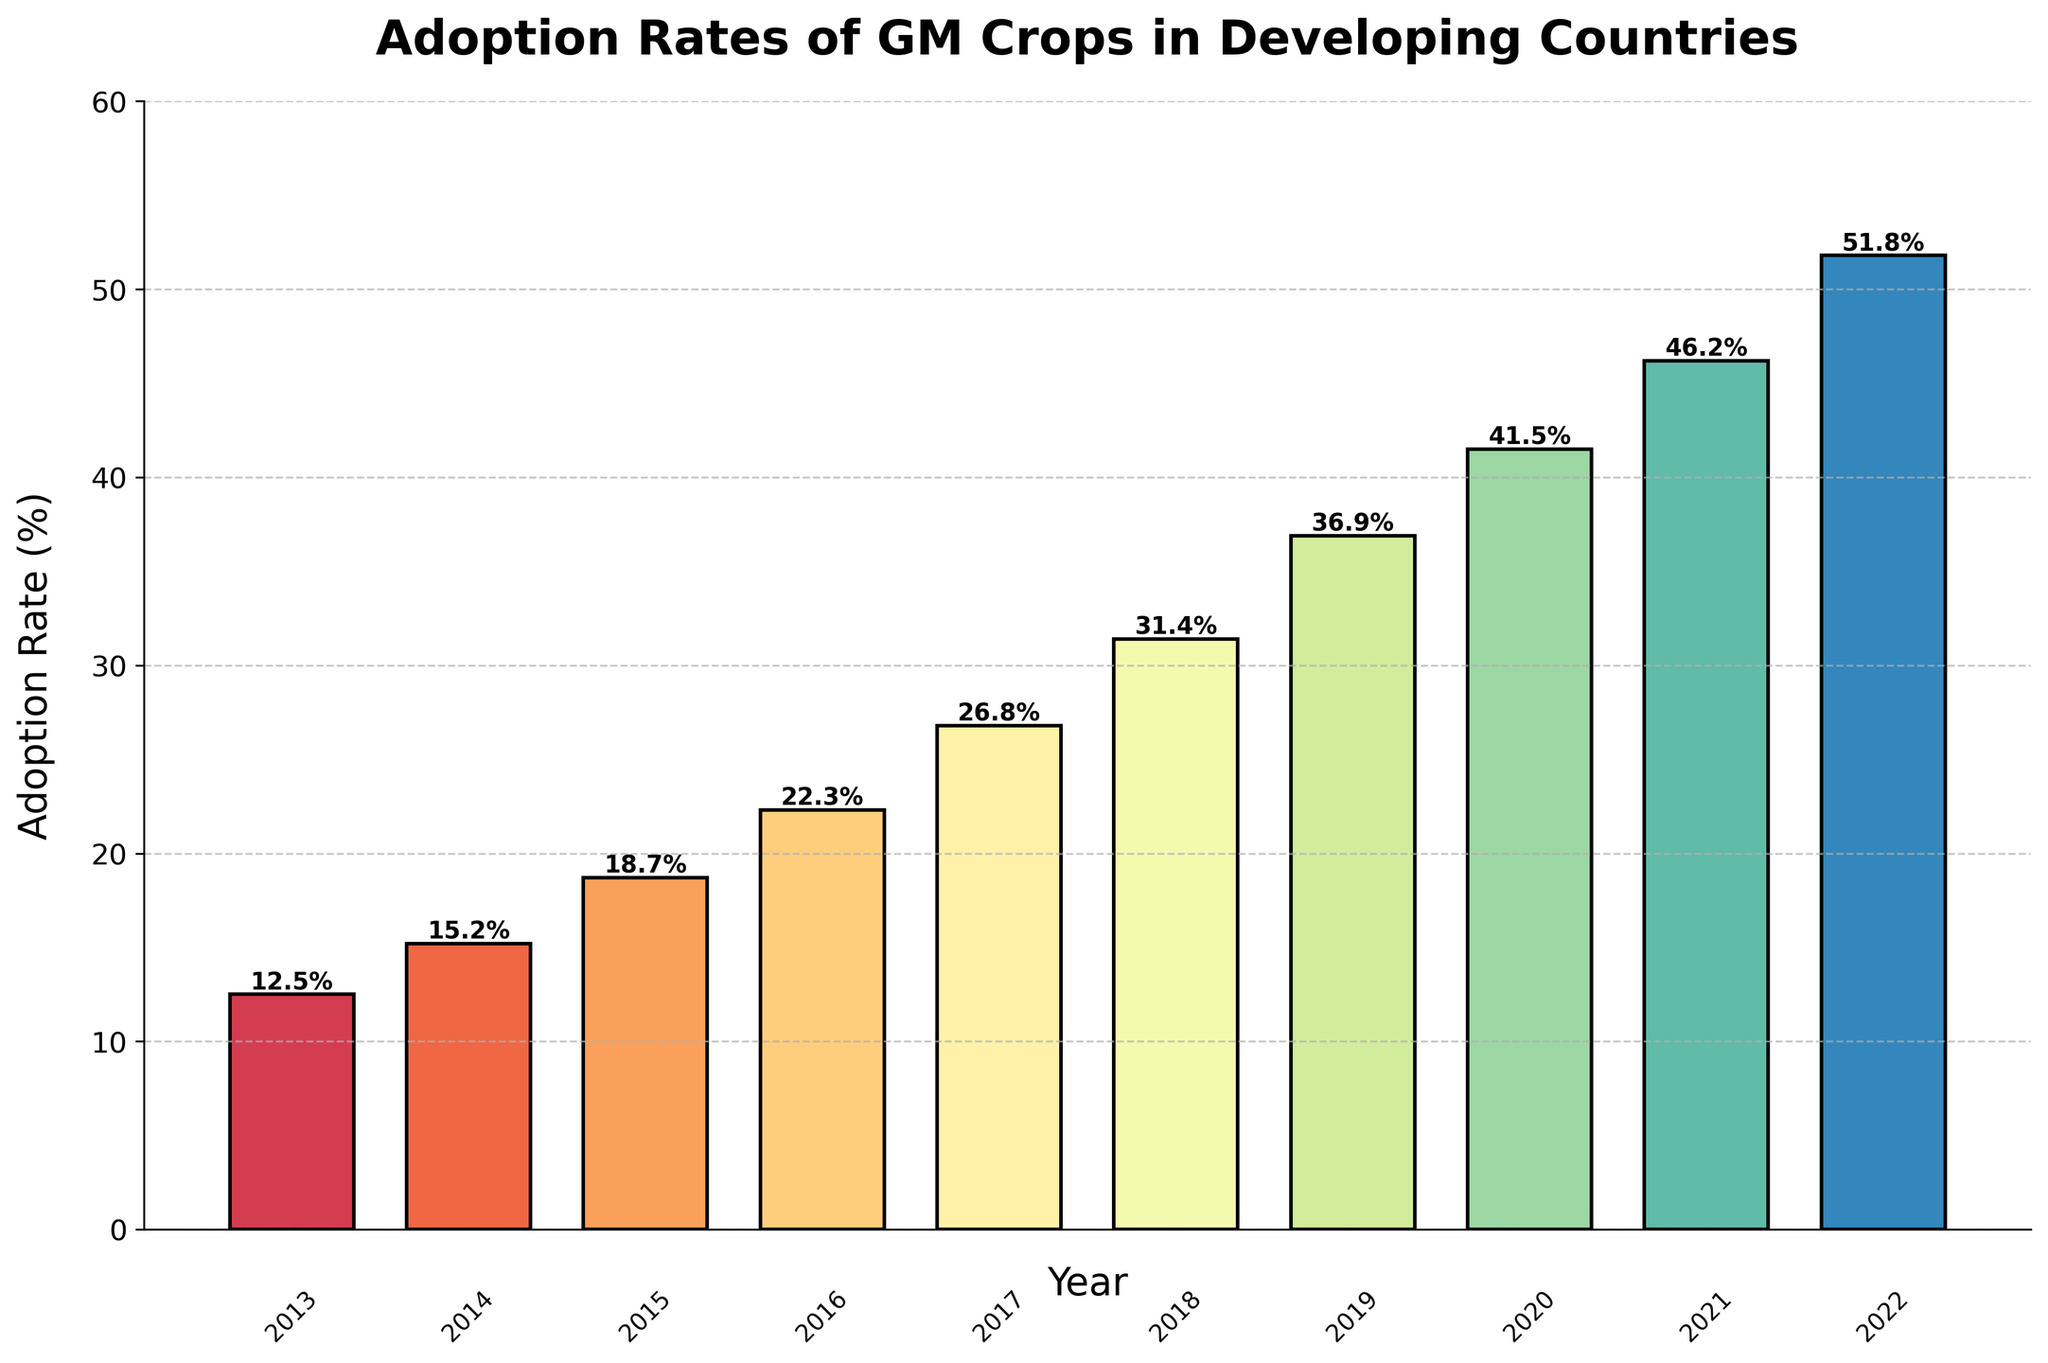What is the adoption rate of GM crops in 2017? The year 2017 corresponds to the label on the x-axis, and the height of the bar at 2017 indicates the adoption rate. The number at the top of the bar also reads 26.8%.
Answer: 26.8% Which year saw the largest adoption rate of GM crops? Observing the height of all the bars, the bar for the year 2022 is the tallest, indicating the highest adoption rate. The number at the top of the bar reads 51.8%.
Answer: 2022 How much did the adoption rate increase from 2013 to 2022? The adoption rate in 2013 is 12.5%, and in 2022 it is 51.8%. Subtracting these values gives the increase: 51.8% - 12.5% = 39.3%.
Answer: 39.3% What was the average adoption rate over the decade? Sum all the adoption rates from 2013 to 2022 and divide by the number of years (10): (12.5 + 15.2 + 18.7 + 22.3 + 26.8 + 31.4 + 36.9 + 41.5 + 46.2 + 51.8) / 10. The total is 303.3, so the average is 303.3 / 10 = 30.33%.
Answer: 30.33% In which year did the adoption rate exceed 40% for the first time? Observing the bars, 2020 is the first year where the adoption rate bar exceeds the 40% mark. The number on top of the bar reads 41.5%.
Answer: 2020 How many years did it take for the adoption rate to double from 12.5%? Starting from 2013 with 12.5%, we look for the year in which the rate is approximately double, i.e., 25%. The bar in 2017 reads 26.8%, which is the first instance exceeding 25%. This is a span of 2017 - 2013 = 4 years.
Answer: 4 Was the increase in adoption rate during 2015-2016 higher or lower than that of 2020-2021? Comparing the values for 2015-2016: 22.3% - 18.7% = 3.6%, and for 2020-2021: 46.2% - 41.5% = 4.7%. The increase during 2020-2021 is higher.
Answer: Higher What is the median adoption rate over the decade? Arrange the adoption rates in ascending order and find the middle value. The list: [12.5, 15.2, 18.7, 22.3, 26.8, 31.4, 36.9, 41.5, 46.2, 51.8]. The median is the average of the 5th and 6th values: (26.8 + 31.4) / 2 = 29.1%.
Answer: 29.1% Which year had the least adoption rate and what was it? The bar with the least height corresponds to the year 2013, with an adoption rate of 12.5%.
Answer: 2013 By how much did the adoption rate grow annually on average between 2018 and 2022? Calculate the annual growth by subtracting the 2018 rate from the 2022 rate, and dividing by the number of intervening years (4): (51.8 - 31.4) / 4 = 5.6%.
Answer: 5.6% 